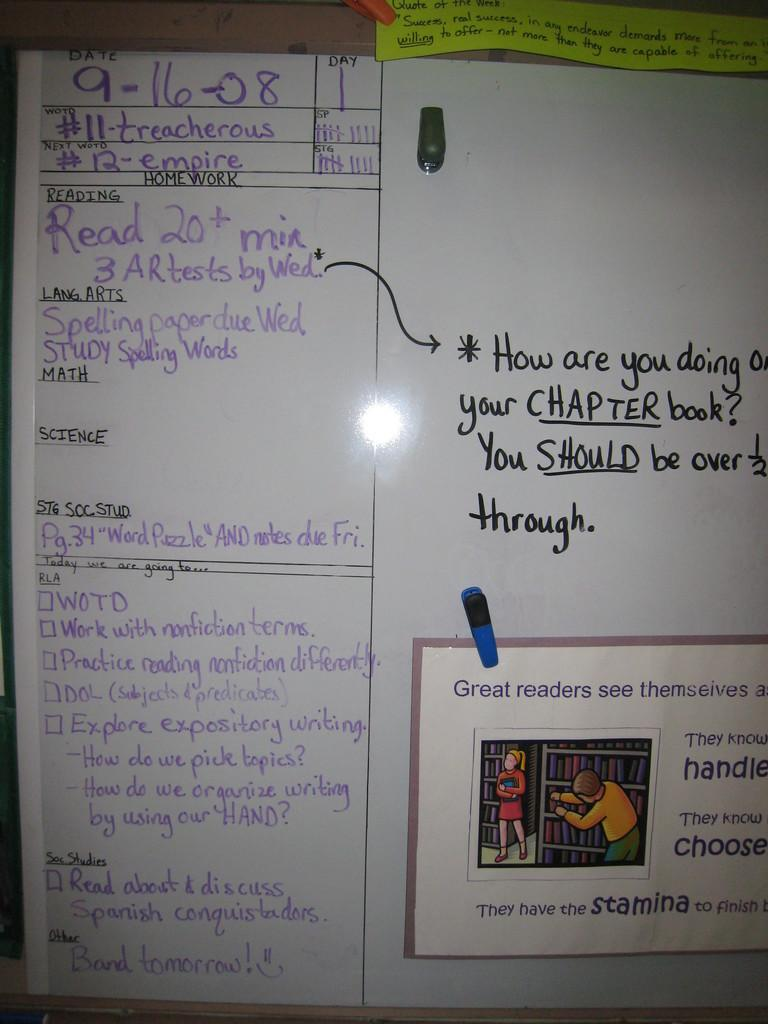Provide a one-sentence caption for the provided image. A white board, dated 9-16-08, displays homework and other class agendas. 